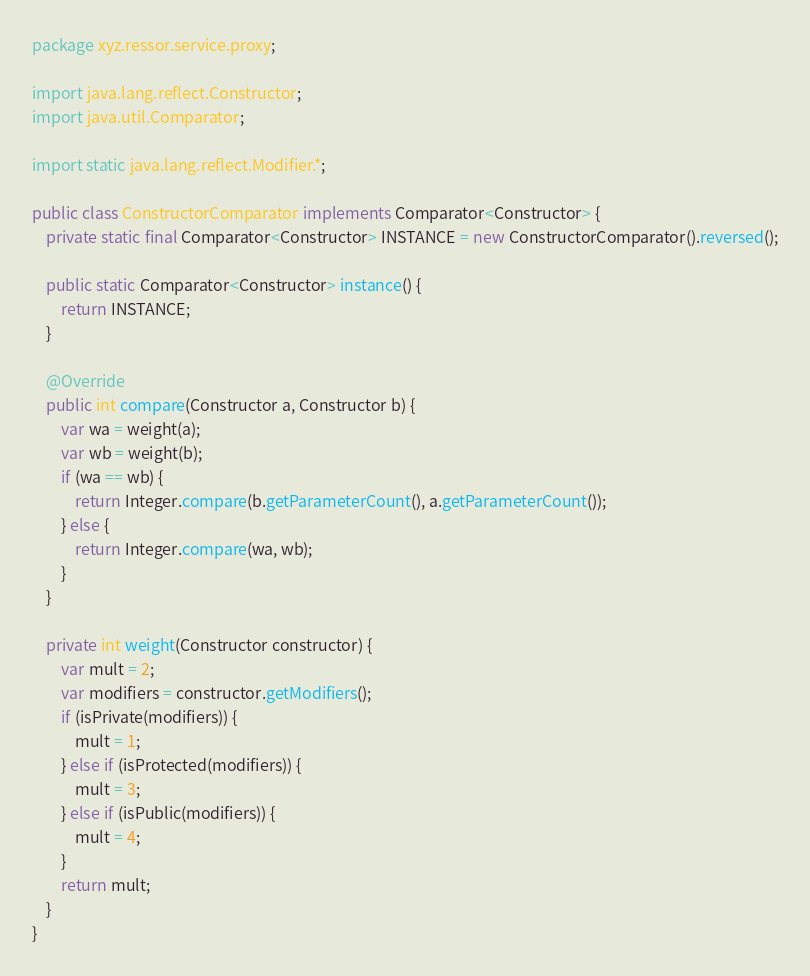Convert code to text. <code><loc_0><loc_0><loc_500><loc_500><_Java_>package xyz.ressor.service.proxy;

import java.lang.reflect.Constructor;
import java.util.Comparator;

import static java.lang.reflect.Modifier.*;

public class ConstructorComparator implements Comparator<Constructor> {
    private static final Comparator<Constructor> INSTANCE = new ConstructorComparator().reversed();

    public static Comparator<Constructor> instance() {
        return INSTANCE;
    }

    @Override
    public int compare(Constructor a, Constructor b) {
        var wa = weight(a);
        var wb = weight(b);
        if (wa == wb) {
            return Integer.compare(b.getParameterCount(), a.getParameterCount());
        } else {
            return Integer.compare(wa, wb);
        }
    }

    private int weight(Constructor constructor) {
        var mult = 2;
        var modifiers = constructor.getModifiers();
        if (isPrivate(modifiers)) {
            mult = 1;
        } else if (isProtected(modifiers)) {
            mult = 3;
        } else if (isPublic(modifiers)) {
            mult = 4;
        }
        return mult;
    }
}
</code> 